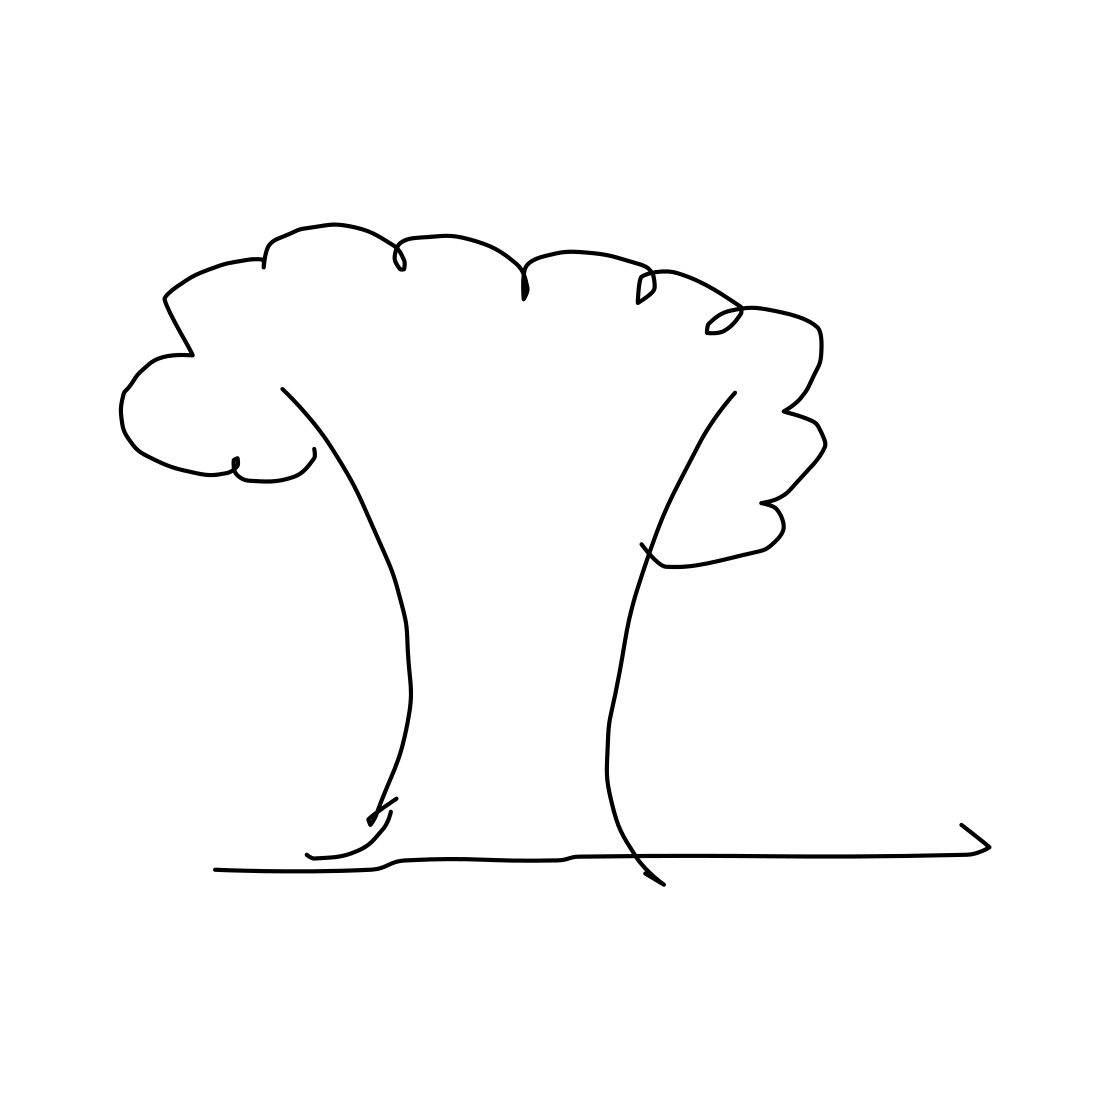Is this a tree in the image? Yes, the image features a stylized, line drawing of a tree with a broad canopy and a bifurcated trunk, resembling a cartoon representation rather than a realistic depiction. 